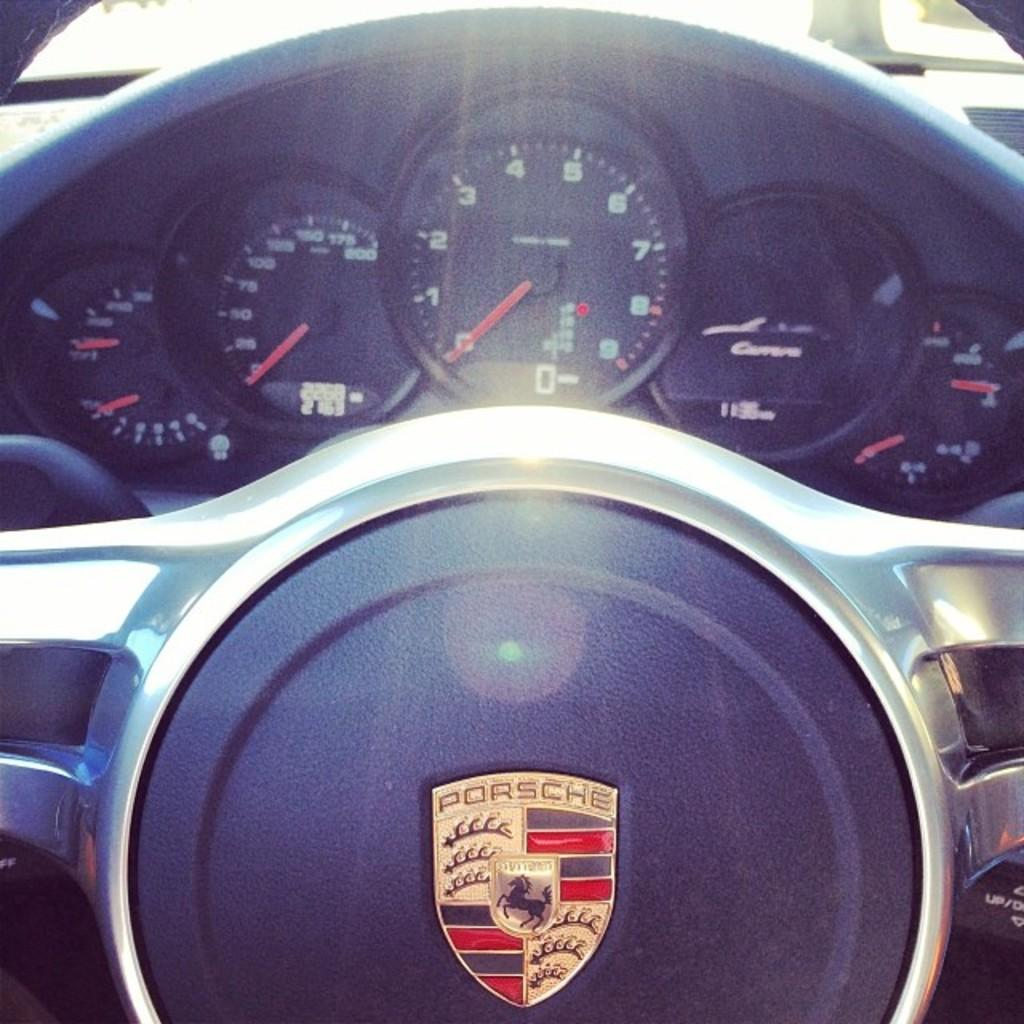What instrument is used to measure the speed of the car in the image? There is a speedometer in the image that measures the speed of the car. What is used to control the direction of the car in the image? There is a steering wheel in the image that is used to control the direction of the car. What type of car is shown in the image? The car in the image is a Porsche. What type of pest can be seen crawling on the speedometer in the image? There are no pests present in the image; it only shows a speedometer, a steering wheel, and a Porsche car. What impulse might the driver have to suddenly change direction while driving the car in the image? The image does not provide information about the driver's impulses or the driving conditions, so we cannot determine any specific impulses. 